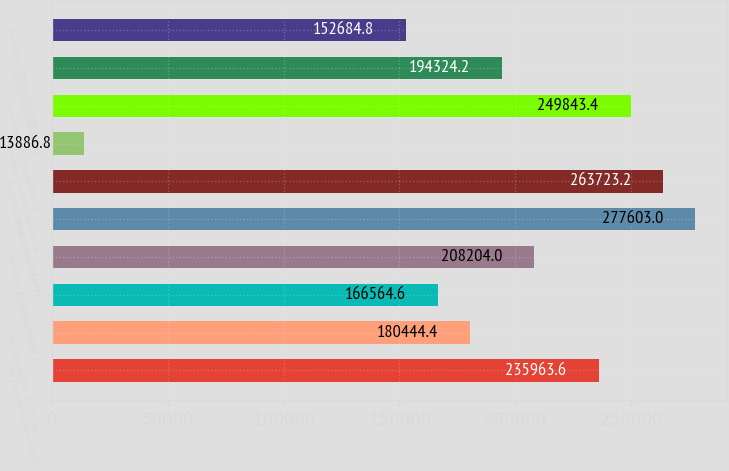Convert chart to OTSL. <chart><loc_0><loc_0><loc_500><loc_500><bar_chart><fcel>Key shareholders' equity<fcel>Less Intangible assets (a)<fcel>Preferred Stock (b)<fcel>Tangible common equity<fcel>Total assets (GAAP)<fcel>Tangible assets (non-GAAP)<fcel>Tangible common equity to<fcel>Average Key shareholders'<fcel>Less Intangible assets<fcel>Preferred Stock (average)<nl><fcel>235964<fcel>180444<fcel>166565<fcel>208204<fcel>277603<fcel>263723<fcel>13886.8<fcel>249843<fcel>194324<fcel>152685<nl></chart> 